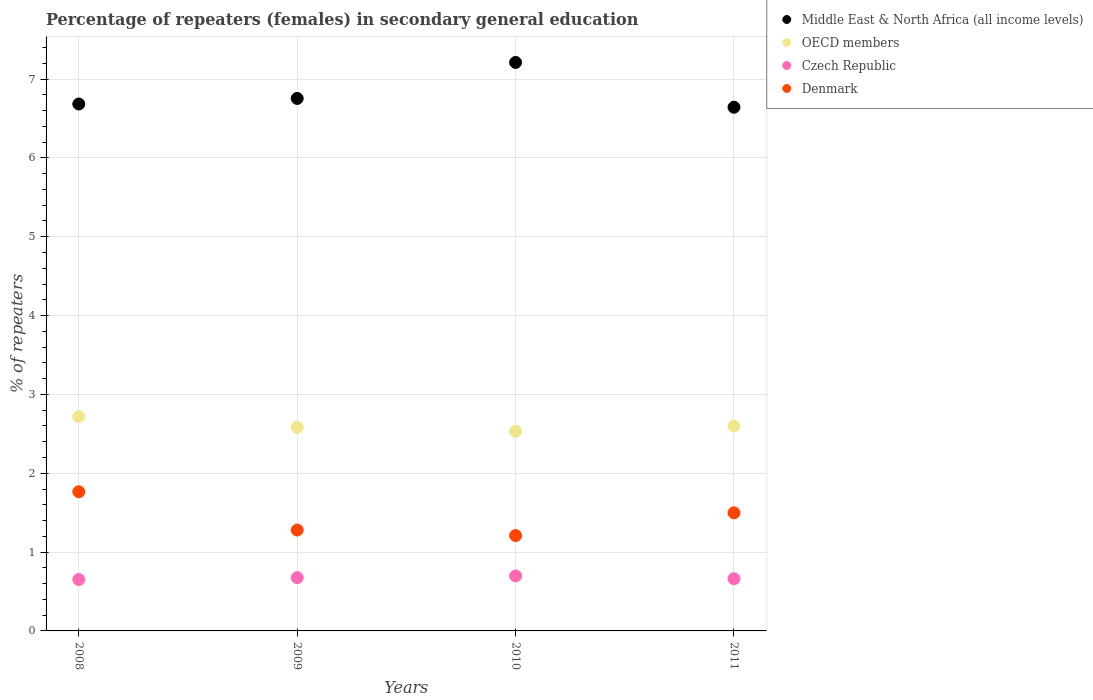How many different coloured dotlines are there?
Give a very brief answer. 4. Is the number of dotlines equal to the number of legend labels?
Make the answer very short. Yes. What is the percentage of female repeaters in Middle East & North Africa (all income levels) in 2009?
Provide a short and direct response. 6.75. Across all years, what is the maximum percentage of female repeaters in Middle East & North Africa (all income levels)?
Offer a terse response. 7.21. Across all years, what is the minimum percentage of female repeaters in Middle East & North Africa (all income levels)?
Ensure brevity in your answer.  6.64. In which year was the percentage of female repeaters in OECD members minimum?
Provide a short and direct response. 2010. What is the total percentage of female repeaters in Middle East & North Africa (all income levels) in the graph?
Make the answer very short. 27.29. What is the difference between the percentage of female repeaters in Czech Republic in 2008 and that in 2010?
Provide a short and direct response. -0.05. What is the difference between the percentage of female repeaters in Middle East & North Africa (all income levels) in 2011 and the percentage of female repeaters in OECD members in 2010?
Provide a succinct answer. 4.11. What is the average percentage of female repeaters in Denmark per year?
Offer a very short reply. 1.44. In the year 2010, what is the difference between the percentage of female repeaters in Denmark and percentage of female repeaters in OECD members?
Offer a terse response. -1.32. What is the ratio of the percentage of female repeaters in OECD members in 2009 to that in 2011?
Ensure brevity in your answer.  0.99. Is the difference between the percentage of female repeaters in Denmark in 2009 and 2010 greater than the difference between the percentage of female repeaters in OECD members in 2009 and 2010?
Keep it short and to the point. Yes. What is the difference between the highest and the second highest percentage of female repeaters in OECD members?
Ensure brevity in your answer.  0.12. What is the difference between the highest and the lowest percentage of female repeaters in Czech Republic?
Your answer should be compact. 0.05. Is the sum of the percentage of female repeaters in Czech Republic in 2009 and 2011 greater than the maximum percentage of female repeaters in Denmark across all years?
Offer a very short reply. No. Is it the case that in every year, the sum of the percentage of female repeaters in Middle East & North Africa (all income levels) and percentage of female repeaters in Czech Republic  is greater than the percentage of female repeaters in Denmark?
Make the answer very short. Yes. Does the percentage of female repeaters in Czech Republic monotonically increase over the years?
Your answer should be very brief. No. Is the percentage of female repeaters in Middle East & North Africa (all income levels) strictly greater than the percentage of female repeaters in OECD members over the years?
Offer a very short reply. Yes. How many years are there in the graph?
Provide a succinct answer. 4. Are the values on the major ticks of Y-axis written in scientific E-notation?
Offer a very short reply. No. Does the graph contain any zero values?
Your answer should be compact. No. What is the title of the graph?
Make the answer very short. Percentage of repeaters (females) in secondary general education. What is the label or title of the Y-axis?
Your answer should be very brief. % of repeaters. What is the % of repeaters in Middle East & North Africa (all income levels) in 2008?
Your answer should be very brief. 6.68. What is the % of repeaters of OECD members in 2008?
Offer a very short reply. 2.72. What is the % of repeaters of Czech Republic in 2008?
Make the answer very short. 0.65. What is the % of repeaters of Denmark in 2008?
Your response must be concise. 1.77. What is the % of repeaters of Middle East & North Africa (all income levels) in 2009?
Ensure brevity in your answer.  6.75. What is the % of repeaters in OECD members in 2009?
Give a very brief answer. 2.58. What is the % of repeaters of Czech Republic in 2009?
Your answer should be compact. 0.68. What is the % of repeaters of Denmark in 2009?
Your answer should be very brief. 1.28. What is the % of repeaters in Middle East & North Africa (all income levels) in 2010?
Ensure brevity in your answer.  7.21. What is the % of repeaters in OECD members in 2010?
Give a very brief answer. 2.53. What is the % of repeaters in Czech Republic in 2010?
Your answer should be very brief. 0.7. What is the % of repeaters in Denmark in 2010?
Offer a very short reply. 1.21. What is the % of repeaters of Middle East & North Africa (all income levels) in 2011?
Ensure brevity in your answer.  6.64. What is the % of repeaters in OECD members in 2011?
Make the answer very short. 2.6. What is the % of repeaters in Czech Republic in 2011?
Provide a short and direct response. 0.66. What is the % of repeaters in Denmark in 2011?
Offer a terse response. 1.5. Across all years, what is the maximum % of repeaters of Middle East & North Africa (all income levels)?
Offer a terse response. 7.21. Across all years, what is the maximum % of repeaters of OECD members?
Provide a succinct answer. 2.72. Across all years, what is the maximum % of repeaters in Czech Republic?
Your answer should be compact. 0.7. Across all years, what is the maximum % of repeaters of Denmark?
Offer a very short reply. 1.77. Across all years, what is the minimum % of repeaters of Middle East & North Africa (all income levels)?
Your response must be concise. 6.64. Across all years, what is the minimum % of repeaters of OECD members?
Your response must be concise. 2.53. Across all years, what is the minimum % of repeaters in Czech Republic?
Make the answer very short. 0.65. Across all years, what is the minimum % of repeaters in Denmark?
Make the answer very short. 1.21. What is the total % of repeaters of Middle East & North Africa (all income levels) in the graph?
Provide a short and direct response. 27.29. What is the total % of repeaters of OECD members in the graph?
Your answer should be very brief. 10.43. What is the total % of repeaters in Czech Republic in the graph?
Keep it short and to the point. 2.69. What is the total % of repeaters in Denmark in the graph?
Offer a terse response. 5.75. What is the difference between the % of repeaters in Middle East & North Africa (all income levels) in 2008 and that in 2009?
Your answer should be very brief. -0.07. What is the difference between the % of repeaters of OECD members in 2008 and that in 2009?
Your answer should be compact. 0.14. What is the difference between the % of repeaters of Czech Republic in 2008 and that in 2009?
Offer a very short reply. -0.02. What is the difference between the % of repeaters of Denmark in 2008 and that in 2009?
Offer a terse response. 0.49. What is the difference between the % of repeaters in Middle East & North Africa (all income levels) in 2008 and that in 2010?
Offer a terse response. -0.53. What is the difference between the % of repeaters in OECD members in 2008 and that in 2010?
Ensure brevity in your answer.  0.19. What is the difference between the % of repeaters of Czech Republic in 2008 and that in 2010?
Your answer should be very brief. -0.04. What is the difference between the % of repeaters in Denmark in 2008 and that in 2010?
Offer a terse response. 0.56. What is the difference between the % of repeaters in Middle East & North Africa (all income levels) in 2008 and that in 2011?
Your response must be concise. 0.04. What is the difference between the % of repeaters in OECD members in 2008 and that in 2011?
Your response must be concise. 0.12. What is the difference between the % of repeaters in Czech Republic in 2008 and that in 2011?
Your response must be concise. -0.01. What is the difference between the % of repeaters of Denmark in 2008 and that in 2011?
Keep it short and to the point. 0.27. What is the difference between the % of repeaters in Middle East & North Africa (all income levels) in 2009 and that in 2010?
Provide a succinct answer. -0.46. What is the difference between the % of repeaters in OECD members in 2009 and that in 2010?
Make the answer very short. 0.05. What is the difference between the % of repeaters in Czech Republic in 2009 and that in 2010?
Your answer should be very brief. -0.02. What is the difference between the % of repeaters of Denmark in 2009 and that in 2010?
Provide a short and direct response. 0.07. What is the difference between the % of repeaters in Middle East & North Africa (all income levels) in 2009 and that in 2011?
Offer a very short reply. 0.11. What is the difference between the % of repeaters of OECD members in 2009 and that in 2011?
Your response must be concise. -0.02. What is the difference between the % of repeaters of Czech Republic in 2009 and that in 2011?
Offer a terse response. 0.01. What is the difference between the % of repeaters in Denmark in 2009 and that in 2011?
Your response must be concise. -0.22. What is the difference between the % of repeaters of Middle East & North Africa (all income levels) in 2010 and that in 2011?
Offer a very short reply. 0.57. What is the difference between the % of repeaters of OECD members in 2010 and that in 2011?
Your answer should be very brief. -0.07. What is the difference between the % of repeaters of Czech Republic in 2010 and that in 2011?
Give a very brief answer. 0.04. What is the difference between the % of repeaters of Denmark in 2010 and that in 2011?
Provide a succinct answer. -0.29. What is the difference between the % of repeaters in Middle East & North Africa (all income levels) in 2008 and the % of repeaters in OECD members in 2009?
Give a very brief answer. 4.1. What is the difference between the % of repeaters of Middle East & North Africa (all income levels) in 2008 and the % of repeaters of Czech Republic in 2009?
Offer a very short reply. 6.01. What is the difference between the % of repeaters of Middle East & North Africa (all income levels) in 2008 and the % of repeaters of Denmark in 2009?
Give a very brief answer. 5.4. What is the difference between the % of repeaters in OECD members in 2008 and the % of repeaters in Czech Republic in 2009?
Give a very brief answer. 2.04. What is the difference between the % of repeaters in OECD members in 2008 and the % of repeaters in Denmark in 2009?
Your answer should be very brief. 1.44. What is the difference between the % of repeaters of Czech Republic in 2008 and the % of repeaters of Denmark in 2009?
Provide a short and direct response. -0.63. What is the difference between the % of repeaters in Middle East & North Africa (all income levels) in 2008 and the % of repeaters in OECD members in 2010?
Offer a terse response. 4.15. What is the difference between the % of repeaters of Middle East & North Africa (all income levels) in 2008 and the % of repeaters of Czech Republic in 2010?
Keep it short and to the point. 5.99. What is the difference between the % of repeaters in Middle East & North Africa (all income levels) in 2008 and the % of repeaters in Denmark in 2010?
Keep it short and to the point. 5.47. What is the difference between the % of repeaters of OECD members in 2008 and the % of repeaters of Czech Republic in 2010?
Offer a terse response. 2.02. What is the difference between the % of repeaters of OECD members in 2008 and the % of repeaters of Denmark in 2010?
Ensure brevity in your answer.  1.51. What is the difference between the % of repeaters of Czech Republic in 2008 and the % of repeaters of Denmark in 2010?
Provide a short and direct response. -0.56. What is the difference between the % of repeaters in Middle East & North Africa (all income levels) in 2008 and the % of repeaters in OECD members in 2011?
Make the answer very short. 4.08. What is the difference between the % of repeaters of Middle East & North Africa (all income levels) in 2008 and the % of repeaters of Czech Republic in 2011?
Your answer should be compact. 6.02. What is the difference between the % of repeaters of Middle East & North Africa (all income levels) in 2008 and the % of repeaters of Denmark in 2011?
Make the answer very short. 5.18. What is the difference between the % of repeaters of OECD members in 2008 and the % of repeaters of Czech Republic in 2011?
Offer a very short reply. 2.06. What is the difference between the % of repeaters of OECD members in 2008 and the % of repeaters of Denmark in 2011?
Make the answer very short. 1.22. What is the difference between the % of repeaters of Czech Republic in 2008 and the % of repeaters of Denmark in 2011?
Offer a very short reply. -0.85. What is the difference between the % of repeaters of Middle East & North Africa (all income levels) in 2009 and the % of repeaters of OECD members in 2010?
Offer a very short reply. 4.22. What is the difference between the % of repeaters of Middle East & North Africa (all income levels) in 2009 and the % of repeaters of Czech Republic in 2010?
Give a very brief answer. 6.06. What is the difference between the % of repeaters of Middle East & North Africa (all income levels) in 2009 and the % of repeaters of Denmark in 2010?
Provide a short and direct response. 5.54. What is the difference between the % of repeaters in OECD members in 2009 and the % of repeaters in Czech Republic in 2010?
Provide a short and direct response. 1.88. What is the difference between the % of repeaters of OECD members in 2009 and the % of repeaters of Denmark in 2010?
Make the answer very short. 1.37. What is the difference between the % of repeaters of Czech Republic in 2009 and the % of repeaters of Denmark in 2010?
Make the answer very short. -0.53. What is the difference between the % of repeaters of Middle East & North Africa (all income levels) in 2009 and the % of repeaters of OECD members in 2011?
Offer a very short reply. 4.15. What is the difference between the % of repeaters of Middle East & North Africa (all income levels) in 2009 and the % of repeaters of Czech Republic in 2011?
Your answer should be very brief. 6.09. What is the difference between the % of repeaters of Middle East & North Africa (all income levels) in 2009 and the % of repeaters of Denmark in 2011?
Provide a short and direct response. 5.26. What is the difference between the % of repeaters of OECD members in 2009 and the % of repeaters of Czech Republic in 2011?
Offer a very short reply. 1.92. What is the difference between the % of repeaters of OECD members in 2009 and the % of repeaters of Denmark in 2011?
Give a very brief answer. 1.08. What is the difference between the % of repeaters in Czech Republic in 2009 and the % of repeaters in Denmark in 2011?
Ensure brevity in your answer.  -0.82. What is the difference between the % of repeaters in Middle East & North Africa (all income levels) in 2010 and the % of repeaters in OECD members in 2011?
Your response must be concise. 4.61. What is the difference between the % of repeaters of Middle East & North Africa (all income levels) in 2010 and the % of repeaters of Czech Republic in 2011?
Make the answer very short. 6.55. What is the difference between the % of repeaters in Middle East & North Africa (all income levels) in 2010 and the % of repeaters in Denmark in 2011?
Ensure brevity in your answer.  5.71. What is the difference between the % of repeaters in OECD members in 2010 and the % of repeaters in Czech Republic in 2011?
Give a very brief answer. 1.87. What is the difference between the % of repeaters in OECD members in 2010 and the % of repeaters in Denmark in 2011?
Provide a short and direct response. 1.03. What is the difference between the % of repeaters of Czech Republic in 2010 and the % of repeaters of Denmark in 2011?
Give a very brief answer. -0.8. What is the average % of repeaters of Middle East & North Africa (all income levels) per year?
Your answer should be compact. 6.82. What is the average % of repeaters in OECD members per year?
Your response must be concise. 2.61. What is the average % of repeaters in Czech Republic per year?
Offer a very short reply. 0.67. What is the average % of repeaters of Denmark per year?
Keep it short and to the point. 1.44. In the year 2008, what is the difference between the % of repeaters of Middle East & North Africa (all income levels) and % of repeaters of OECD members?
Give a very brief answer. 3.96. In the year 2008, what is the difference between the % of repeaters in Middle East & North Africa (all income levels) and % of repeaters in Czech Republic?
Ensure brevity in your answer.  6.03. In the year 2008, what is the difference between the % of repeaters in Middle East & North Africa (all income levels) and % of repeaters in Denmark?
Offer a very short reply. 4.92. In the year 2008, what is the difference between the % of repeaters in OECD members and % of repeaters in Czech Republic?
Give a very brief answer. 2.07. In the year 2008, what is the difference between the % of repeaters of OECD members and % of repeaters of Denmark?
Make the answer very short. 0.95. In the year 2008, what is the difference between the % of repeaters of Czech Republic and % of repeaters of Denmark?
Ensure brevity in your answer.  -1.11. In the year 2009, what is the difference between the % of repeaters in Middle East & North Africa (all income levels) and % of repeaters in OECD members?
Your response must be concise. 4.17. In the year 2009, what is the difference between the % of repeaters of Middle East & North Africa (all income levels) and % of repeaters of Czech Republic?
Offer a terse response. 6.08. In the year 2009, what is the difference between the % of repeaters in Middle East & North Africa (all income levels) and % of repeaters in Denmark?
Your answer should be very brief. 5.47. In the year 2009, what is the difference between the % of repeaters in OECD members and % of repeaters in Czech Republic?
Provide a short and direct response. 1.91. In the year 2009, what is the difference between the % of repeaters of OECD members and % of repeaters of Denmark?
Your answer should be compact. 1.3. In the year 2009, what is the difference between the % of repeaters in Czech Republic and % of repeaters in Denmark?
Your response must be concise. -0.6. In the year 2010, what is the difference between the % of repeaters in Middle East & North Africa (all income levels) and % of repeaters in OECD members?
Your answer should be very brief. 4.68. In the year 2010, what is the difference between the % of repeaters in Middle East & North Africa (all income levels) and % of repeaters in Czech Republic?
Your answer should be very brief. 6.51. In the year 2010, what is the difference between the % of repeaters in Middle East & North Africa (all income levels) and % of repeaters in Denmark?
Offer a very short reply. 6. In the year 2010, what is the difference between the % of repeaters in OECD members and % of repeaters in Czech Republic?
Offer a terse response. 1.84. In the year 2010, what is the difference between the % of repeaters in OECD members and % of repeaters in Denmark?
Offer a very short reply. 1.32. In the year 2010, what is the difference between the % of repeaters of Czech Republic and % of repeaters of Denmark?
Your response must be concise. -0.51. In the year 2011, what is the difference between the % of repeaters of Middle East & North Africa (all income levels) and % of repeaters of OECD members?
Provide a short and direct response. 4.04. In the year 2011, what is the difference between the % of repeaters in Middle East & North Africa (all income levels) and % of repeaters in Czech Republic?
Make the answer very short. 5.98. In the year 2011, what is the difference between the % of repeaters of Middle East & North Africa (all income levels) and % of repeaters of Denmark?
Keep it short and to the point. 5.14. In the year 2011, what is the difference between the % of repeaters in OECD members and % of repeaters in Czech Republic?
Your answer should be compact. 1.94. In the year 2011, what is the difference between the % of repeaters of OECD members and % of repeaters of Denmark?
Offer a terse response. 1.1. In the year 2011, what is the difference between the % of repeaters in Czech Republic and % of repeaters in Denmark?
Your answer should be compact. -0.84. What is the ratio of the % of repeaters in Middle East & North Africa (all income levels) in 2008 to that in 2009?
Your response must be concise. 0.99. What is the ratio of the % of repeaters in OECD members in 2008 to that in 2009?
Give a very brief answer. 1.05. What is the ratio of the % of repeaters of Czech Republic in 2008 to that in 2009?
Provide a succinct answer. 0.97. What is the ratio of the % of repeaters of Denmark in 2008 to that in 2009?
Your response must be concise. 1.38. What is the ratio of the % of repeaters in Middle East & North Africa (all income levels) in 2008 to that in 2010?
Offer a terse response. 0.93. What is the ratio of the % of repeaters of OECD members in 2008 to that in 2010?
Your answer should be compact. 1.07. What is the ratio of the % of repeaters in Czech Republic in 2008 to that in 2010?
Ensure brevity in your answer.  0.94. What is the ratio of the % of repeaters in Denmark in 2008 to that in 2010?
Your response must be concise. 1.46. What is the ratio of the % of repeaters in Middle East & North Africa (all income levels) in 2008 to that in 2011?
Offer a very short reply. 1.01. What is the ratio of the % of repeaters in OECD members in 2008 to that in 2011?
Keep it short and to the point. 1.05. What is the ratio of the % of repeaters of Czech Republic in 2008 to that in 2011?
Ensure brevity in your answer.  0.99. What is the ratio of the % of repeaters of Denmark in 2008 to that in 2011?
Provide a succinct answer. 1.18. What is the ratio of the % of repeaters in Middle East & North Africa (all income levels) in 2009 to that in 2010?
Make the answer very short. 0.94. What is the ratio of the % of repeaters of OECD members in 2009 to that in 2010?
Give a very brief answer. 1.02. What is the ratio of the % of repeaters in Czech Republic in 2009 to that in 2010?
Ensure brevity in your answer.  0.97. What is the ratio of the % of repeaters in Denmark in 2009 to that in 2010?
Give a very brief answer. 1.06. What is the ratio of the % of repeaters in Middle East & North Africa (all income levels) in 2009 to that in 2011?
Offer a very short reply. 1.02. What is the ratio of the % of repeaters of OECD members in 2009 to that in 2011?
Provide a short and direct response. 0.99. What is the ratio of the % of repeaters of Czech Republic in 2009 to that in 2011?
Your answer should be very brief. 1.02. What is the ratio of the % of repeaters in Denmark in 2009 to that in 2011?
Ensure brevity in your answer.  0.85. What is the ratio of the % of repeaters in Middle East & North Africa (all income levels) in 2010 to that in 2011?
Make the answer very short. 1.09. What is the ratio of the % of repeaters of OECD members in 2010 to that in 2011?
Your answer should be compact. 0.97. What is the ratio of the % of repeaters in Czech Republic in 2010 to that in 2011?
Give a very brief answer. 1.05. What is the ratio of the % of repeaters of Denmark in 2010 to that in 2011?
Offer a very short reply. 0.81. What is the difference between the highest and the second highest % of repeaters of Middle East & North Africa (all income levels)?
Keep it short and to the point. 0.46. What is the difference between the highest and the second highest % of repeaters in OECD members?
Offer a very short reply. 0.12. What is the difference between the highest and the second highest % of repeaters in Czech Republic?
Your response must be concise. 0.02. What is the difference between the highest and the second highest % of repeaters of Denmark?
Provide a succinct answer. 0.27. What is the difference between the highest and the lowest % of repeaters in Middle East & North Africa (all income levels)?
Your answer should be compact. 0.57. What is the difference between the highest and the lowest % of repeaters in OECD members?
Keep it short and to the point. 0.19. What is the difference between the highest and the lowest % of repeaters of Czech Republic?
Provide a succinct answer. 0.04. What is the difference between the highest and the lowest % of repeaters of Denmark?
Make the answer very short. 0.56. 